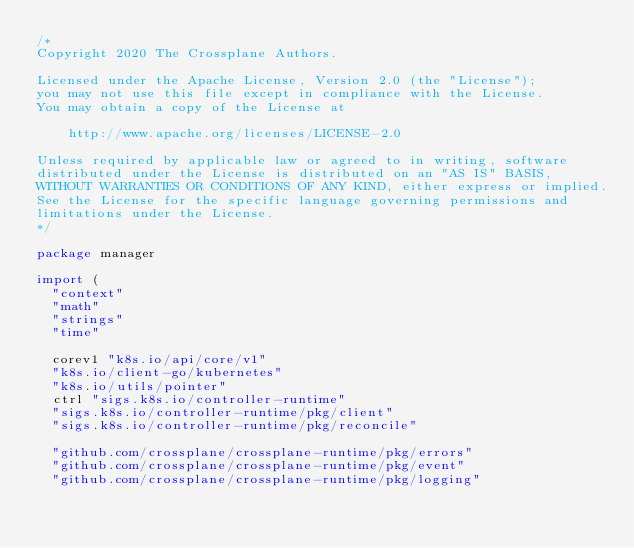Convert code to text. <code><loc_0><loc_0><loc_500><loc_500><_Go_>/*
Copyright 2020 The Crossplane Authors.

Licensed under the Apache License, Version 2.0 (the "License");
you may not use this file except in compliance with the License.
You may obtain a copy of the License at

    http://www.apache.org/licenses/LICENSE-2.0

Unless required by applicable law or agreed to in writing, software
distributed under the License is distributed on an "AS IS" BASIS,
WITHOUT WARRANTIES OR CONDITIONS OF ANY KIND, either express or implied.
See the License for the specific language governing permissions and
limitations under the License.
*/

package manager

import (
	"context"
	"math"
	"strings"
	"time"

	corev1 "k8s.io/api/core/v1"
	"k8s.io/client-go/kubernetes"
	"k8s.io/utils/pointer"
	ctrl "sigs.k8s.io/controller-runtime"
	"sigs.k8s.io/controller-runtime/pkg/client"
	"sigs.k8s.io/controller-runtime/pkg/reconcile"

	"github.com/crossplane/crossplane-runtime/pkg/errors"
	"github.com/crossplane/crossplane-runtime/pkg/event"
	"github.com/crossplane/crossplane-runtime/pkg/logging"</code> 